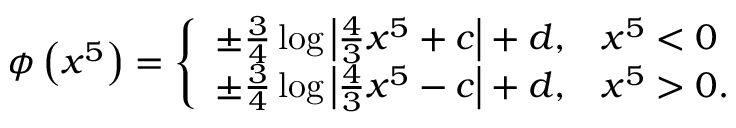Convert formula to latex. <formula><loc_0><loc_0><loc_500><loc_500>\phi \left ( x ^ { 5 } \right ) = \left \{ \begin{array} { l l } { { \pm \frac { 3 } { 4 } \log \left | \frac { 4 } { 3 } x ^ { 5 } + c \right | + d , } } & { { x ^ { 5 } < 0 } } \\ { { \pm \frac { 3 } { 4 } \log \left | \frac { 4 } { 3 } x ^ { 5 } - c \right | + d , } } & { { x ^ { 5 } > 0 . } } \end{array}</formula> 